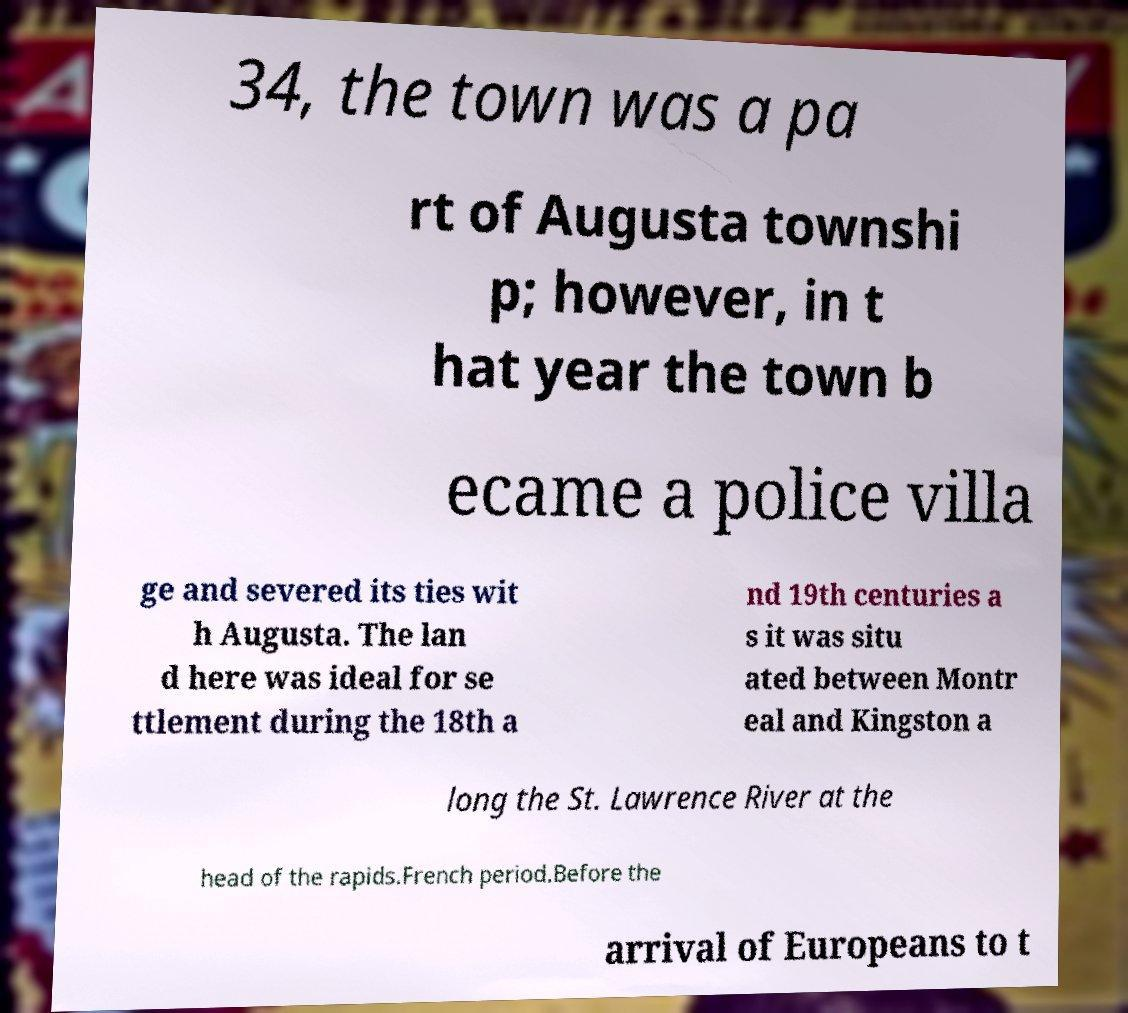I need the written content from this picture converted into text. Can you do that? 34, the town was a pa rt of Augusta townshi p; however, in t hat year the town b ecame a police villa ge and severed its ties wit h Augusta. The lan d here was ideal for se ttlement during the 18th a nd 19th centuries a s it was situ ated between Montr eal and Kingston a long the St. Lawrence River at the head of the rapids.French period.Before the arrival of Europeans to t 